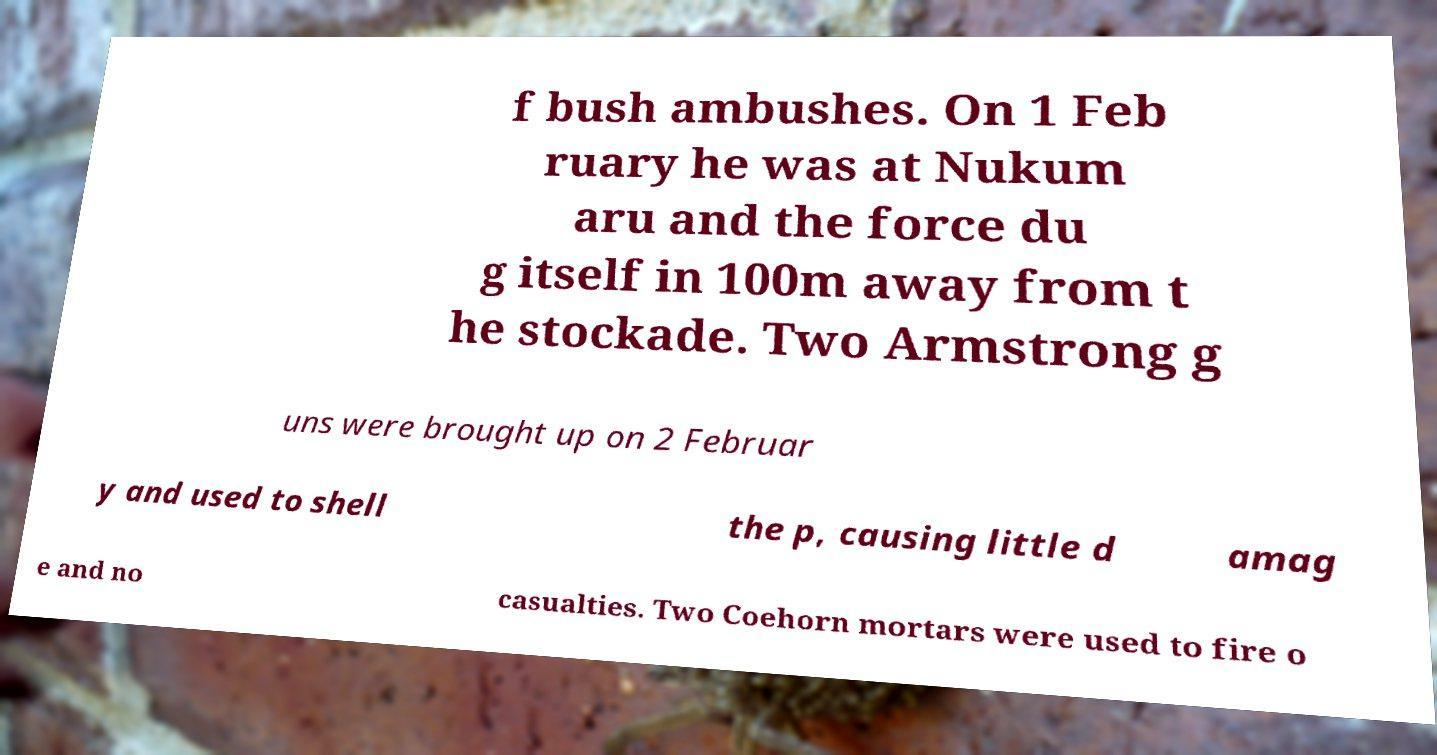Could you assist in decoding the text presented in this image and type it out clearly? f bush ambushes. On 1 Feb ruary he was at Nukum aru and the force du g itself in 100m away from t he stockade. Two Armstrong g uns were brought up on 2 Februar y and used to shell the p, causing little d amag e and no casualties. Two Coehorn mortars were used to fire o 